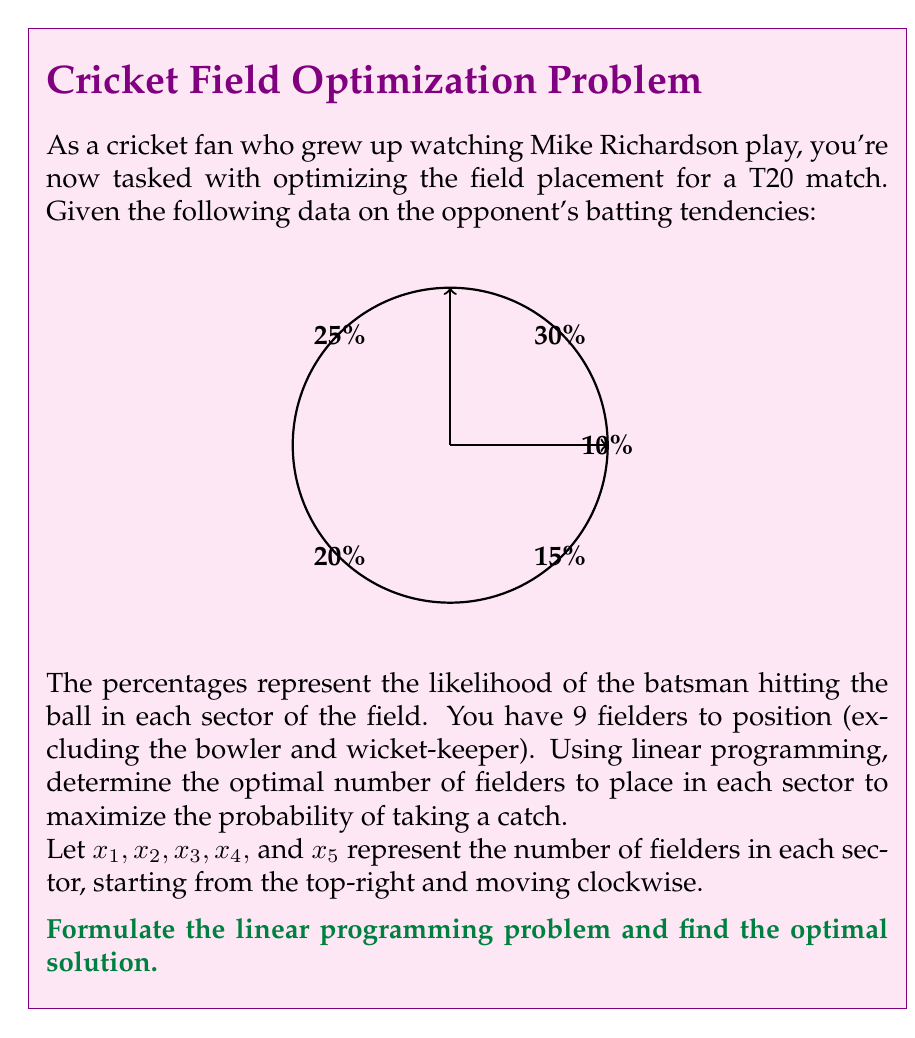Could you help me with this problem? To solve this problem using linear programming, we need to follow these steps:

1. Define the objective function:
   We want to maximize the probability of taking a catch, which is the sum of the products of each sector's probability and the number of fielders placed there.

   Maximize: $Z = 0.30x_1 + 0.25x_2 + 0.20x_3 + 0.15x_4 + 0.10x_5$

2. Set up the constraints:
   a) Total number of fielders: $x_1 + x_2 + x_3 + x_4 + x_5 = 9$
   b) Non-negativity: $x_1, x_2, x_3, x_4, x_5 \geq 0$
   c) Integer values: $x_1, x_2, x_3, x_4, x_5$ must be integers

3. Solve the linear programming problem:
   This is an integer programming problem, which can be solved using various methods such as the branch and bound algorithm. However, given the small scale of the problem, we can use a simple heuristic approach:

   - Allocate fielders to the sectors with the highest probabilities first.
   - Distribute any remaining fielders to the next highest probability sectors.

4. Following this heuristic:
   - Allocate 3 fielders to sector 1 (30%)
   - Allocate 3 fielders to sector 2 (25%)
   - Allocate 2 fielders to sector 3 (20%)
   - Allocate 1 fielder to sector 4 (15%)
   - Allocate 0 fielders to sector 5 (10%)

5. Verify the solution:
   $x_1 = 3, x_2 = 3, x_3 = 2, x_4 = 1, x_5 = 0$
   Total fielders: $3 + 3 + 2 + 1 + 0 = 9$
   Objective function value: $Z = 0.30(3) + 0.25(3) + 0.20(2) + 0.15(1) + 0.10(0) = 2.05$

This solution satisfies all constraints and maximizes the probability of taking a catch given the batsman's tendencies.
Answer: $x_1 = 3, x_2 = 3, x_3 = 2, x_4 = 1, x_5 = 0$ 